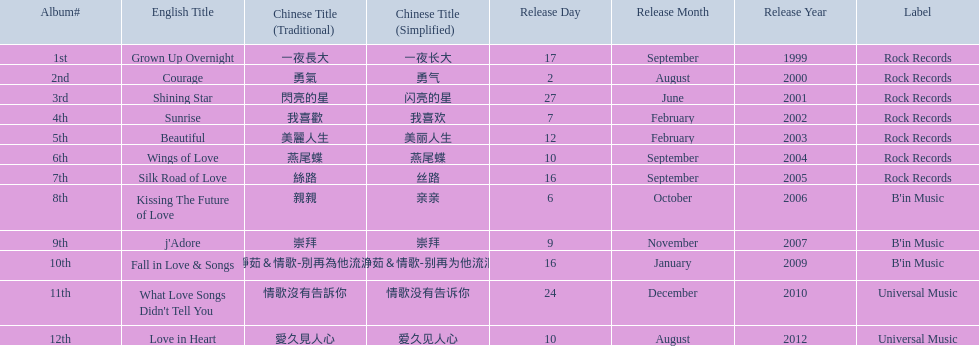What were the albums? Grown Up Overnight, Courage, Shining Star, Sunrise, Beautiful, Wings of Love, Silk Road of Love, Kissing The Future of Love, j'Adore, Fall in Love & Songs, What Love Songs Didn't Tell You, Love in Heart. Which ones were released by b'in music? Kissing The Future of Love, j'Adore. Of these, which one was in an even-numbered year? Kissing The Future of Love. 